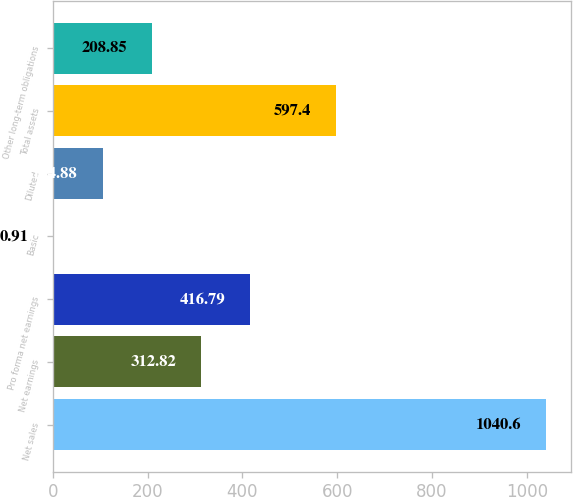<chart> <loc_0><loc_0><loc_500><loc_500><bar_chart><fcel>Net sales<fcel>Net earnings<fcel>Pro forma net earnings<fcel>Basic<fcel>Diluted<fcel>Total assets<fcel>Other long-term obligations<nl><fcel>1040.6<fcel>312.82<fcel>416.79<fcel>0.91<fcel>104.88<fcel>597.4<fcel>208.85<nl></chart> 